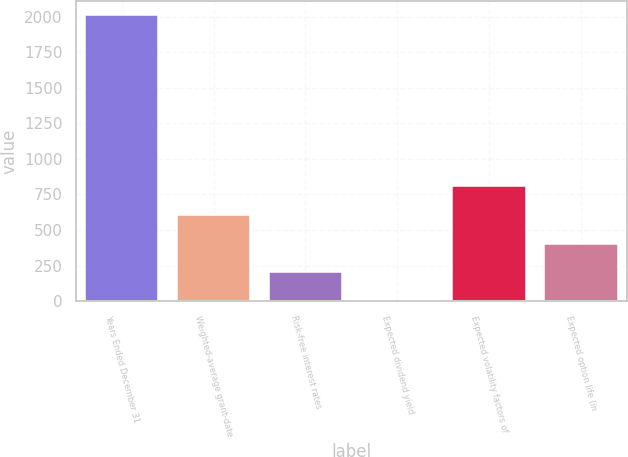Convert chart. <chart><loc_0><loc_0><loc_500><loc_500><bar_chart><fcel>Years Ended December 31<fcel>Weighted-average grant-date<fcel>Risk-free interest rates<fcel>Expected dividend yield<fcel>Expected volatility factors of<fcel>Expected option life (in<nl><fcel>2011<fcel>605.4<fcel>203.8<fcel>3<fcel>806.2<fcel>404.6<nl></chart> 